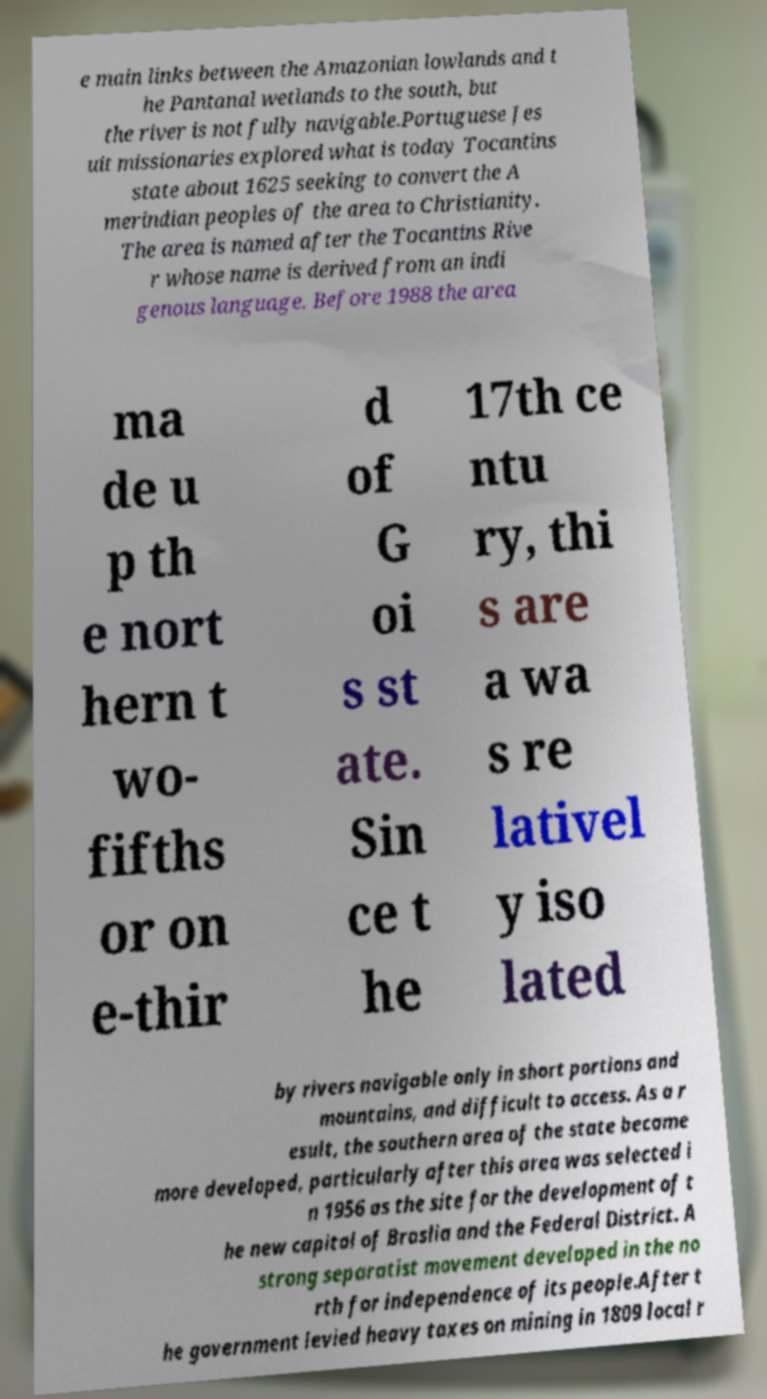There's text embedded in this image that I need extracted. Can you transcribe it verbatim? e main links between the Amazonian lowlands and t he Pantanal wetlands to the south, but the river is not fully navigable.Portuguese Jes uit missionaries explored what is today Tocantins state about 1625 seeking to convert the A merindian peoples of the area to Christianity. The area is named after the Tocantins Rive r whose name is derived from an indi genous language. Before 1988 the area ma de u p th e nort hern t wo- fifths or on e-thir d of G oi s st ate. Sin ce t he 17th ce ntu ry, thi s are a wa s re lativel y iso lated by rivers navigable only in short portions and mountains, and difficult to access. As a r esult, the southern area of the state became more developed, particularly after this area was selected i n 1956 as the site for the development of t he new capital of Braslia and the Federal District. A strong separatist movement developed in the no rth for independence of its people.After t he government levied heavy taxes on mining in 1809 local r 